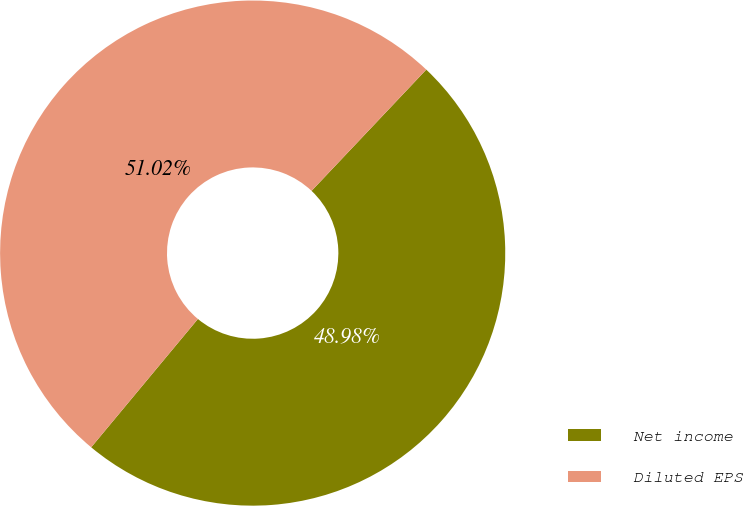Convert chart. <chart><loc_0><loc_0><loc_500><loc_500><pie_chart><fcel>Net income<fcel>Diluted EPS<nl><fcel>48.98%<fcel>51.02%<nl></chart> 